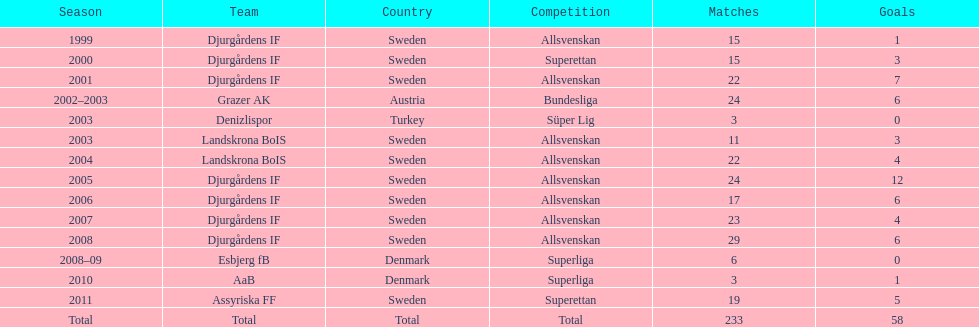What is the overall number of goals scored by jones kusi-asare? 58. 